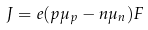<formula> <loc_0><loc_0><loc_500><loc_500>J = e ( p \mu _ { p } - n \mu _ { n } ) F</formula> 